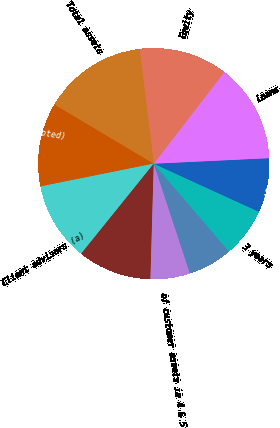<chart> <loc_0><loc_0><loc_500><loc_500><pie_chart><fcel>otherwise noted)<fcel>Client advisors (a)<fcel>Retirement planning services<fcel>of customer assets in 4 & 5<fcel>1 year<fcel>3 years<fcel>5 years<fcel>Loans<fcel>Equity<fcel>Total assets<nl><fcel>11.72%<fcel>11.03%<fcel>10.34%<fcel>5.52%<fcel>6.21%<fcel>6.9%<fcel>7.59%<fcel>13.79%<fcel>12.41%<fcel>14.48%<nl></chart> 